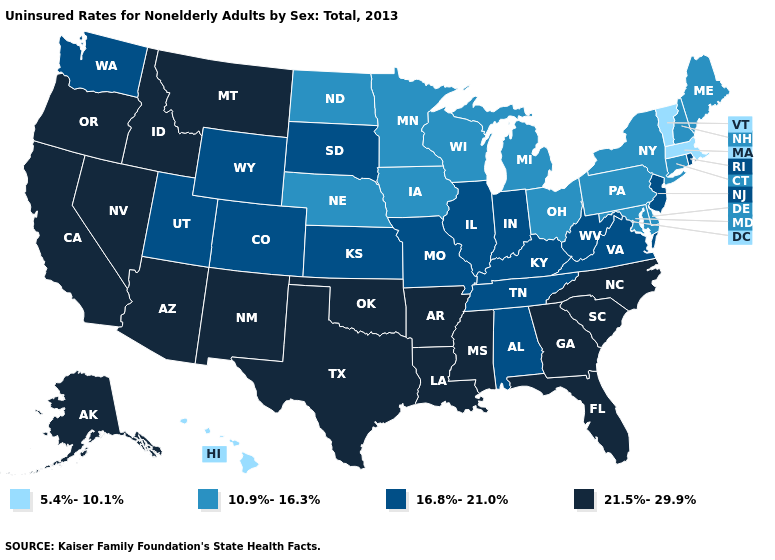What is the value of Nebraska?
Answer briefly. 10.9%-16.3%. Name the states that have a value in the range 10.9%-16.3%?
Concise answer only. Connecticut, Delaware, Iowa, Maine, Maryland, Michigan, Minnesota, Nebraska, New Hampshire, New York, North Dakota, Ohio, Pennsylvania, Wisconsin. Does the map have missing data?
Be succinct. No. Does Utah have a lower value than Georgia?
Give a very brief answer. Yes. Name the states that have a value in the range 16.8%-21.0%?
Give a very brief answer. Alabama, Colorado, Illinois, Indiana, Kansas, Kentucky, Missouri, New Jersey, Rhode Island, South Dakota, Tennessee, Utah, Virginia, Washington, West Virginia, Wyoming. Name the states that have a value in the range 10.9%-16.3%?
Quick response, please. Connecticut, Delaware, Iowa, Maine, Maryland, Michigan, Minnesota, Nebraska, New Hampshire, New York, North Dakota, Ohio, Pennsylvania, Wisconsin. What is the highest value in the MidWest ?
Be succinct. 16.8%-21.0%. Does Arkansas have the highest value in the USA?
Answer briefly. Yes. Does Oklahoma have the lowest value in the South?
Give a very brief answer. No. Does Maryland have a lower value than Wisconsin?
Write a very short answer. No. What is the value of South Carolina?
Concise answer only. 21.5%-29.9%. What is the value of Massachusetts?
Write a very short answer. 5.4%-10.1%. Which states have the highest value in the USA?
Concise answer only. Alaska, Arizona, Arkansas, California, Florida, Georgia, Idaho, Louisiana, Mississippi, Montana, Nevada, New Mexico, North Carolina, Oklahoma, Oregon, South Carolina, Texas. Does the map have missing data?
Keep it brief. No. What is the lowest value in the West?
Keep it brief. 5.4%-10.1%. 